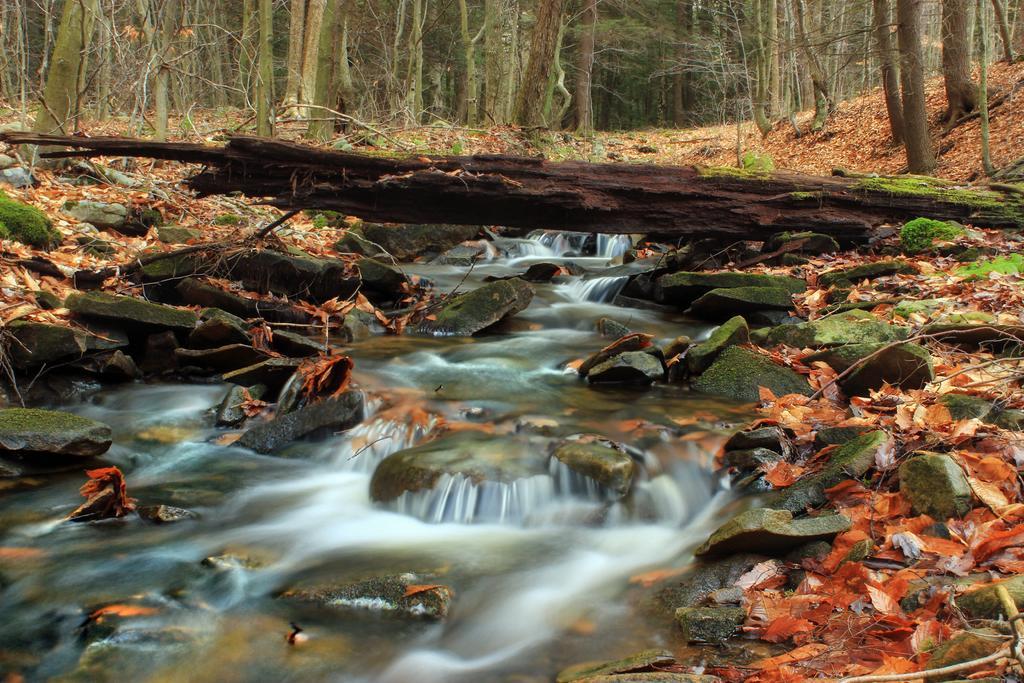How would you summarize this image in a sentence or two? In the picture we can see a water flowing from the stones and near to it we can see a some grass and trees. 